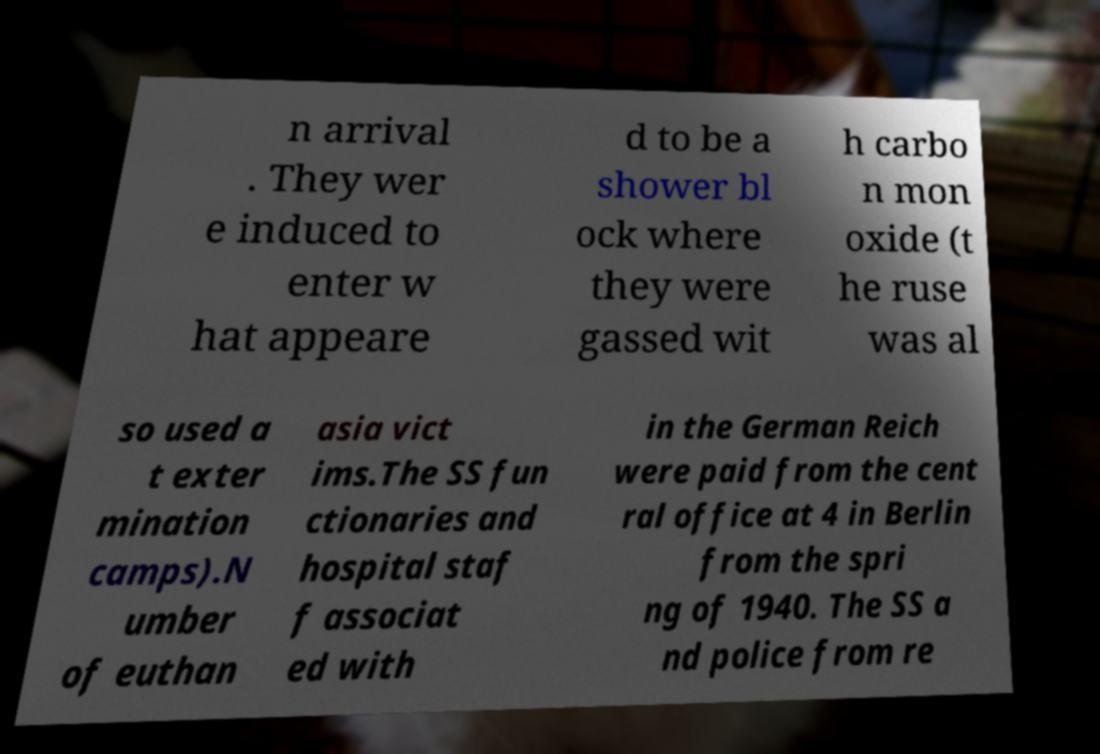Could you extract and type out the text from this image? n arrival . They wer e induced to enter w hat appeare d to be a shower bl ock where they were gassed wit h carbo n mon oxide (t he ruse was al so used a t exter mination camps).N umber of euthan asia vict ims.The SS fun ctionaries and hospital staf f associat ed with in the German Reich were paid from the cent ral office at 4 in Berlin from the spri ng of 1940. The SS a nd police from re 